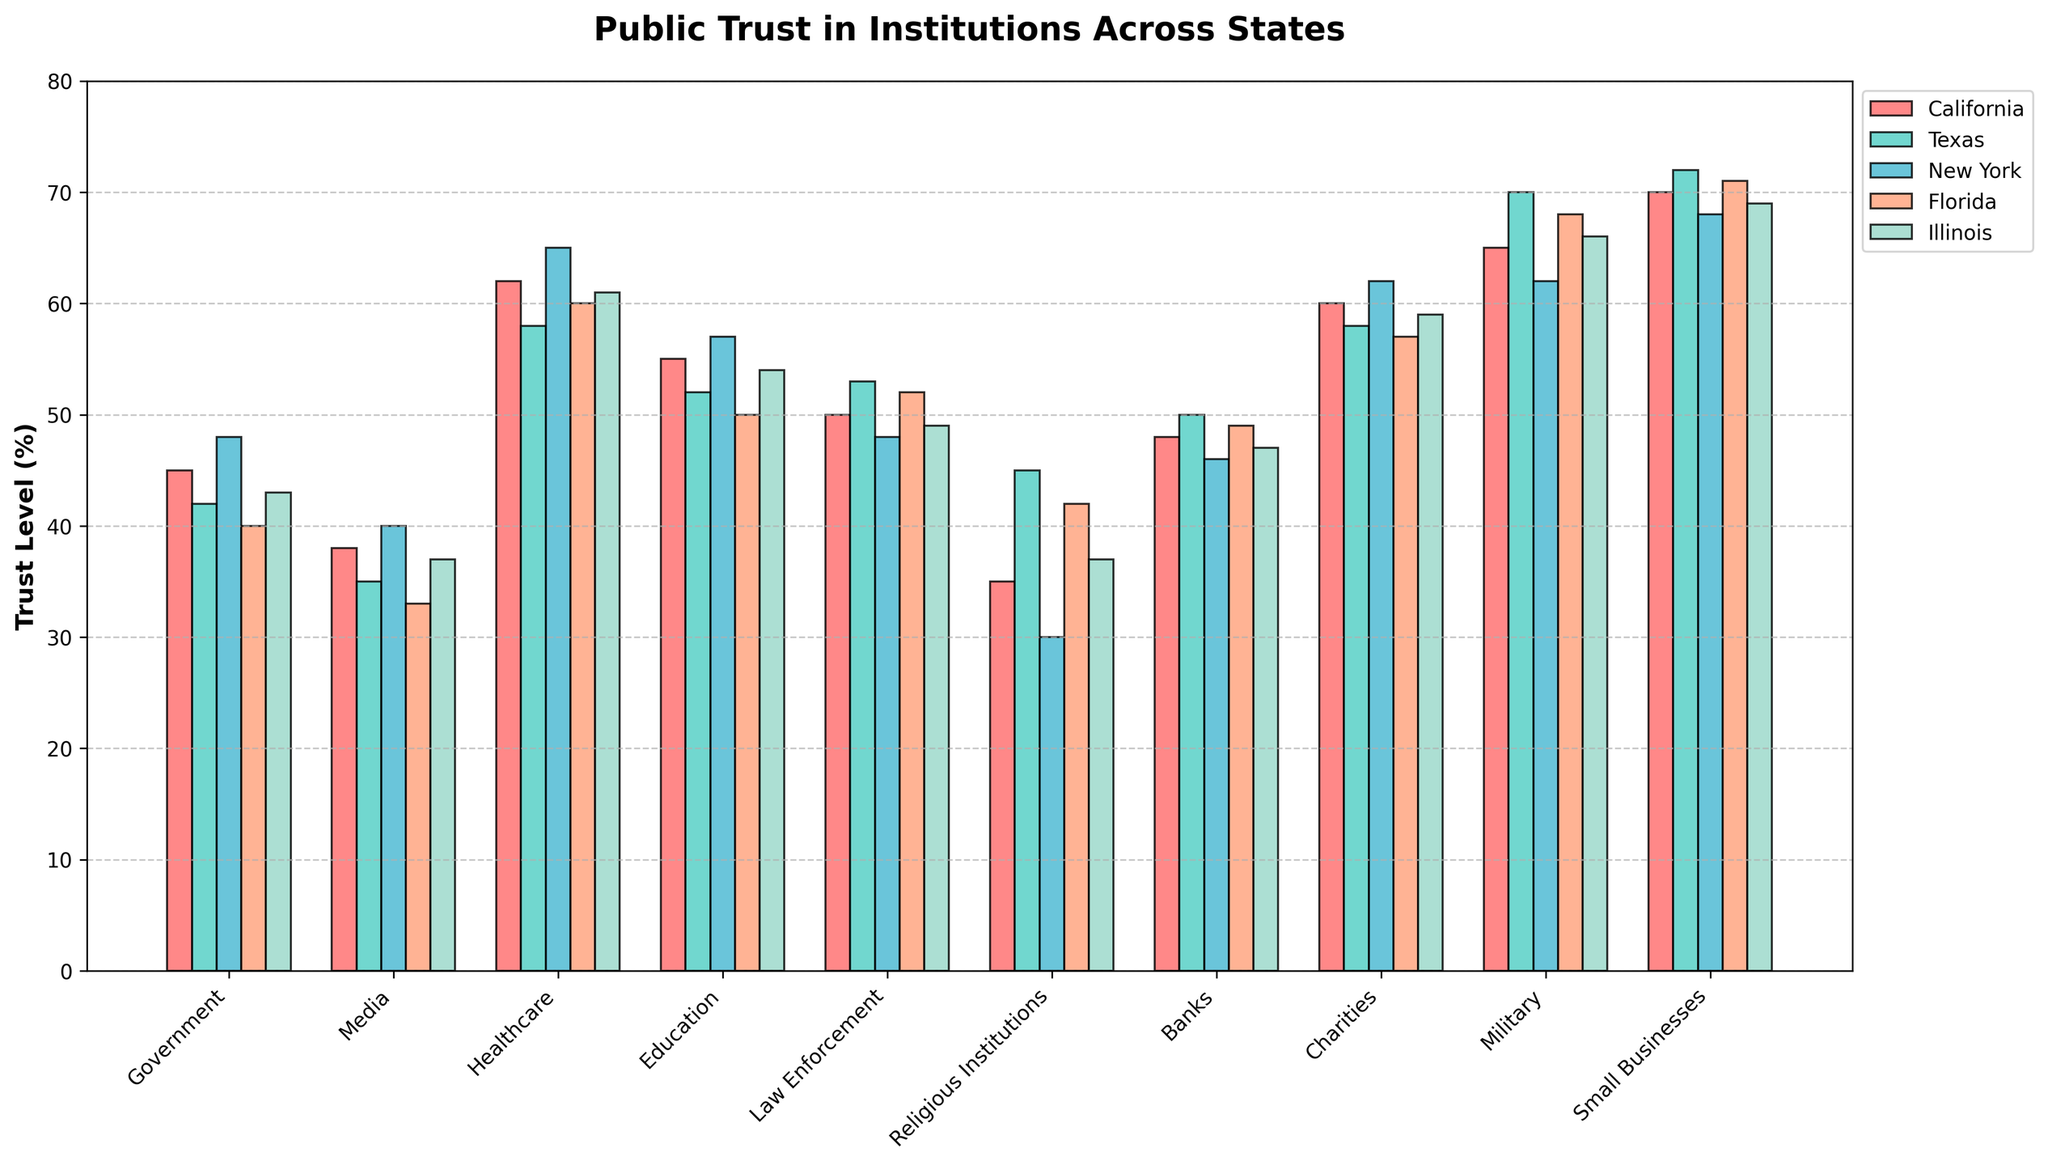What institution has the highest trust level in California? The bar corresponding to the institution "Small Businesses" is the highest in California, showing that it has the highest trust level.
Answer: Small Businesses Which state has the lowest trust level in media? According to the bar chart, Florida has the shortest bar in the Media category, indicating the lowest trust level.
Answer: Florida What's the difference in trust levels for healthcare between the highest and lowest states? New York has the highest trust in healthcare at 65%, and Texas has the lowest at 58%. The difference is 65 - 58 = 7%.
Answer: 7% In which state do charities have the highest trust level? By observing the heights of the bars for Charities, New York has the highest bar at 62%.
Answer: New York What is the combined trust level in law enforcement and education in Florida? The trust levels in law enforcement and education in Florida are 52% and 50%, respectively. The combined trust level is 52 + 50 = 102%.
Answer: 102% Which institution has the lowest trust level in Illinois? The shortest bar in Illinois corresponds to Religious Institutions with 37%.
Answer: Religious Institutions Compare the trust levels in government between Texas and California. In the figure, the bar for government trust in Texas is at 42%, while California is at 45%. California is higher by 3%.
Answer: California is higher by 3% What is the average trust level in the military across all states? The trust levels in the military across states are 65 (California), 70 (Texas), 62 (New York), 68 (Florida), and 66 (Illinois). The average is (65 + 70 + 62 + 68 + 66) / 5 = 66.2.
Answer: 66.2 Which two institutions in New York have equal trust levels? By inspecting the bars in New York, Government and Law Enforcement both have trust levels at 48%.
Answer: Government and Law Enforcement What state has the highest overall trust in government, media, healthcare, and education combined? Summing the individual trust levels for each institution in the specified categories: 
California: 45 + 38 + 62 + 55 = 200
Texas: 42 + 35 + 58 + 52 = 187
New York: 48 + 40 + 65 + 57 = 210
Florida: 40 + 33 + 60 + 50 = 183
Illinois: 43 + 37 + 61 + 54 = 195
New York has the highest combined total of 210.
Answer: New York 